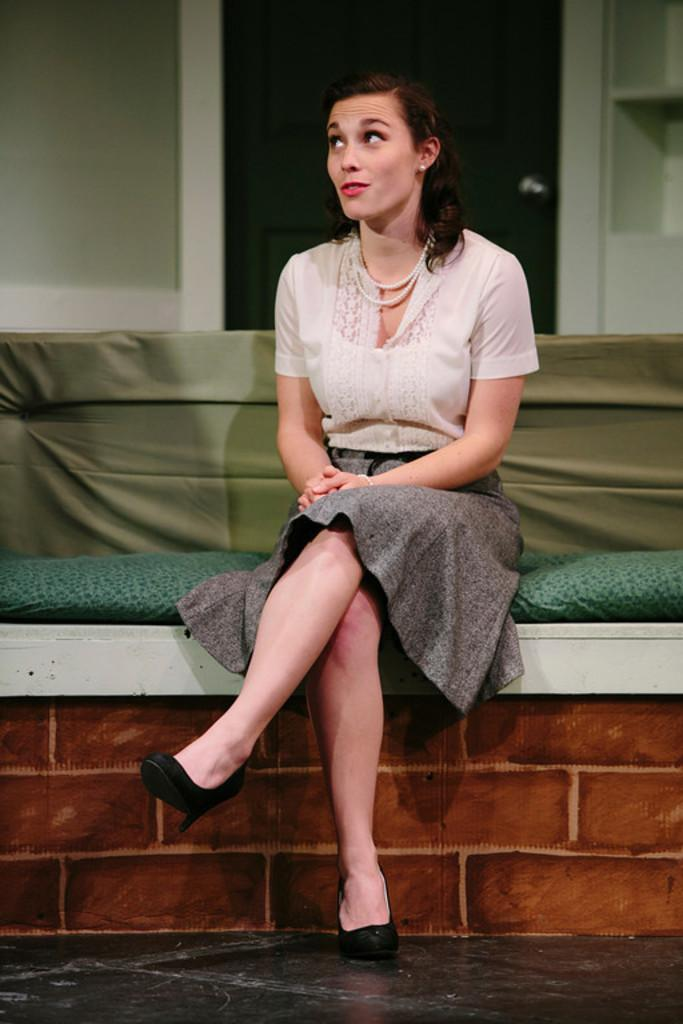Who is the main subject in the image? There is a woman in the image. What is the woman wearing? The woman is wearing a white shirt. What is the woman doing in the image? The woman is sitting on a bench. What can be seen in the background of the image? There are shelves in the background of the image. Where is the baby in the image? There is no baby present in the image. What type of alley can be seen in the image? There is no alley present in the image. 